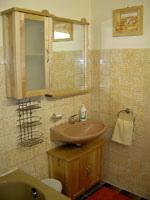What is the wall treatment here?
Keep it brief. Tile. Where is the soap?
Quick response, please. Sink. Is there a reflection in the mirror?
Answer briefly. Yes. 